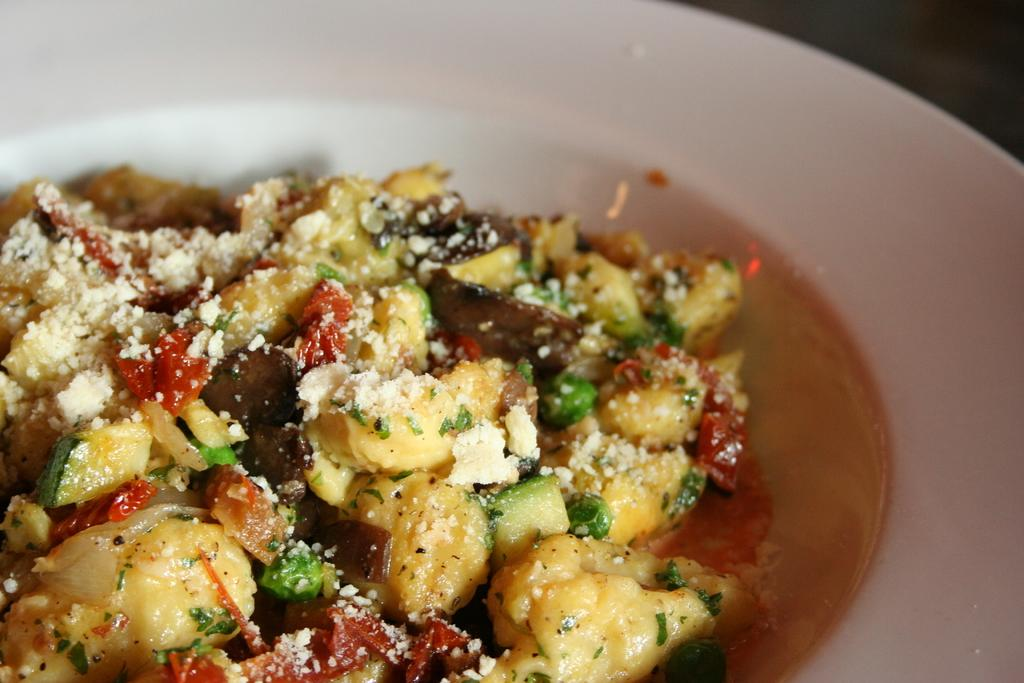What is the main object in the image? There is a white color palette in the image. What is the purpose of the palette? The palette contains food items. Can you tell me how many goats are standing on the palette in the image? There are no goats present in the image; it features a white color palette with food items. What is the chance of the food items balancing perfectly on the palette? The image does not provide information about the balance of the food items on the palette, so it is impossible to determine the chance of them balancing perfectly. 